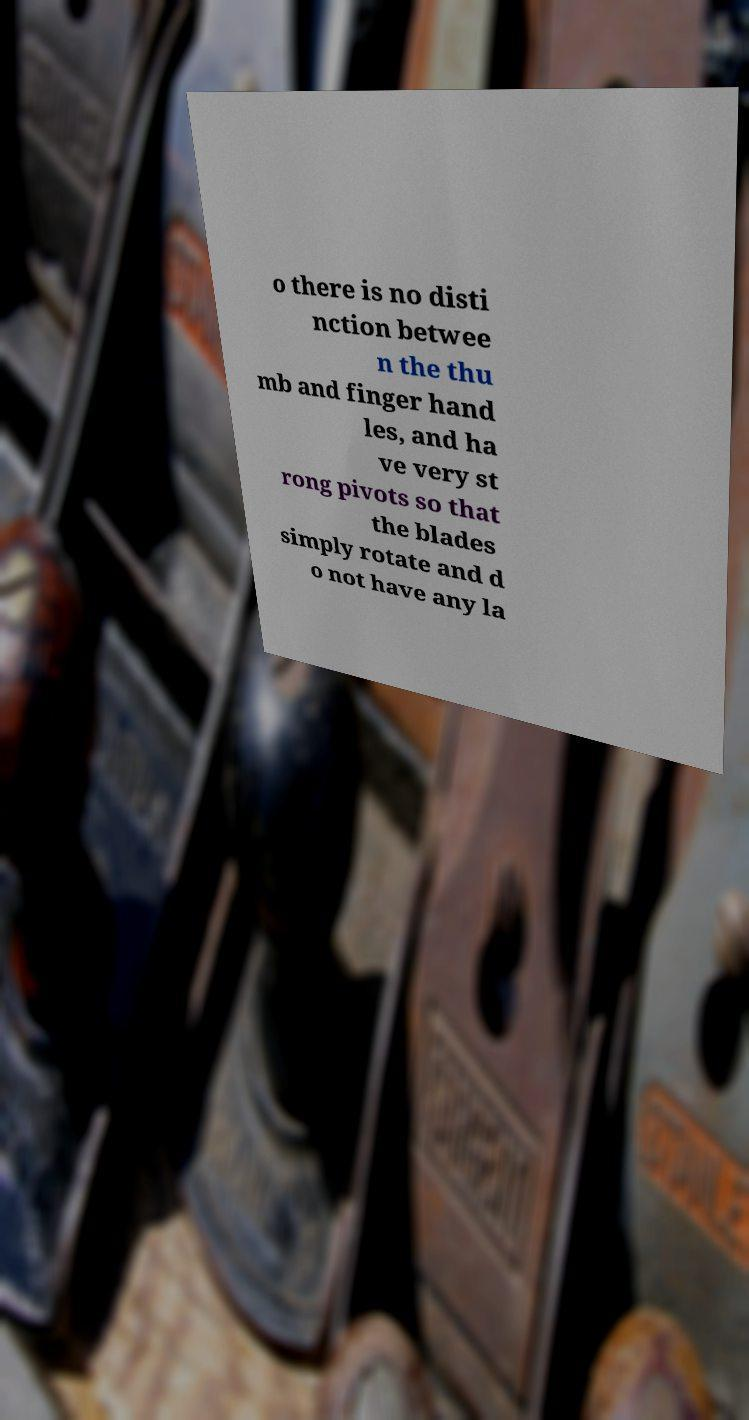What messages or text are displayed in this image? I need them in a readable, typed format. o there is no disti nction betwee n the thu mb and finger hand les, and ha ve very st rong pivots so that the blades simply rotate and d o not have any la 